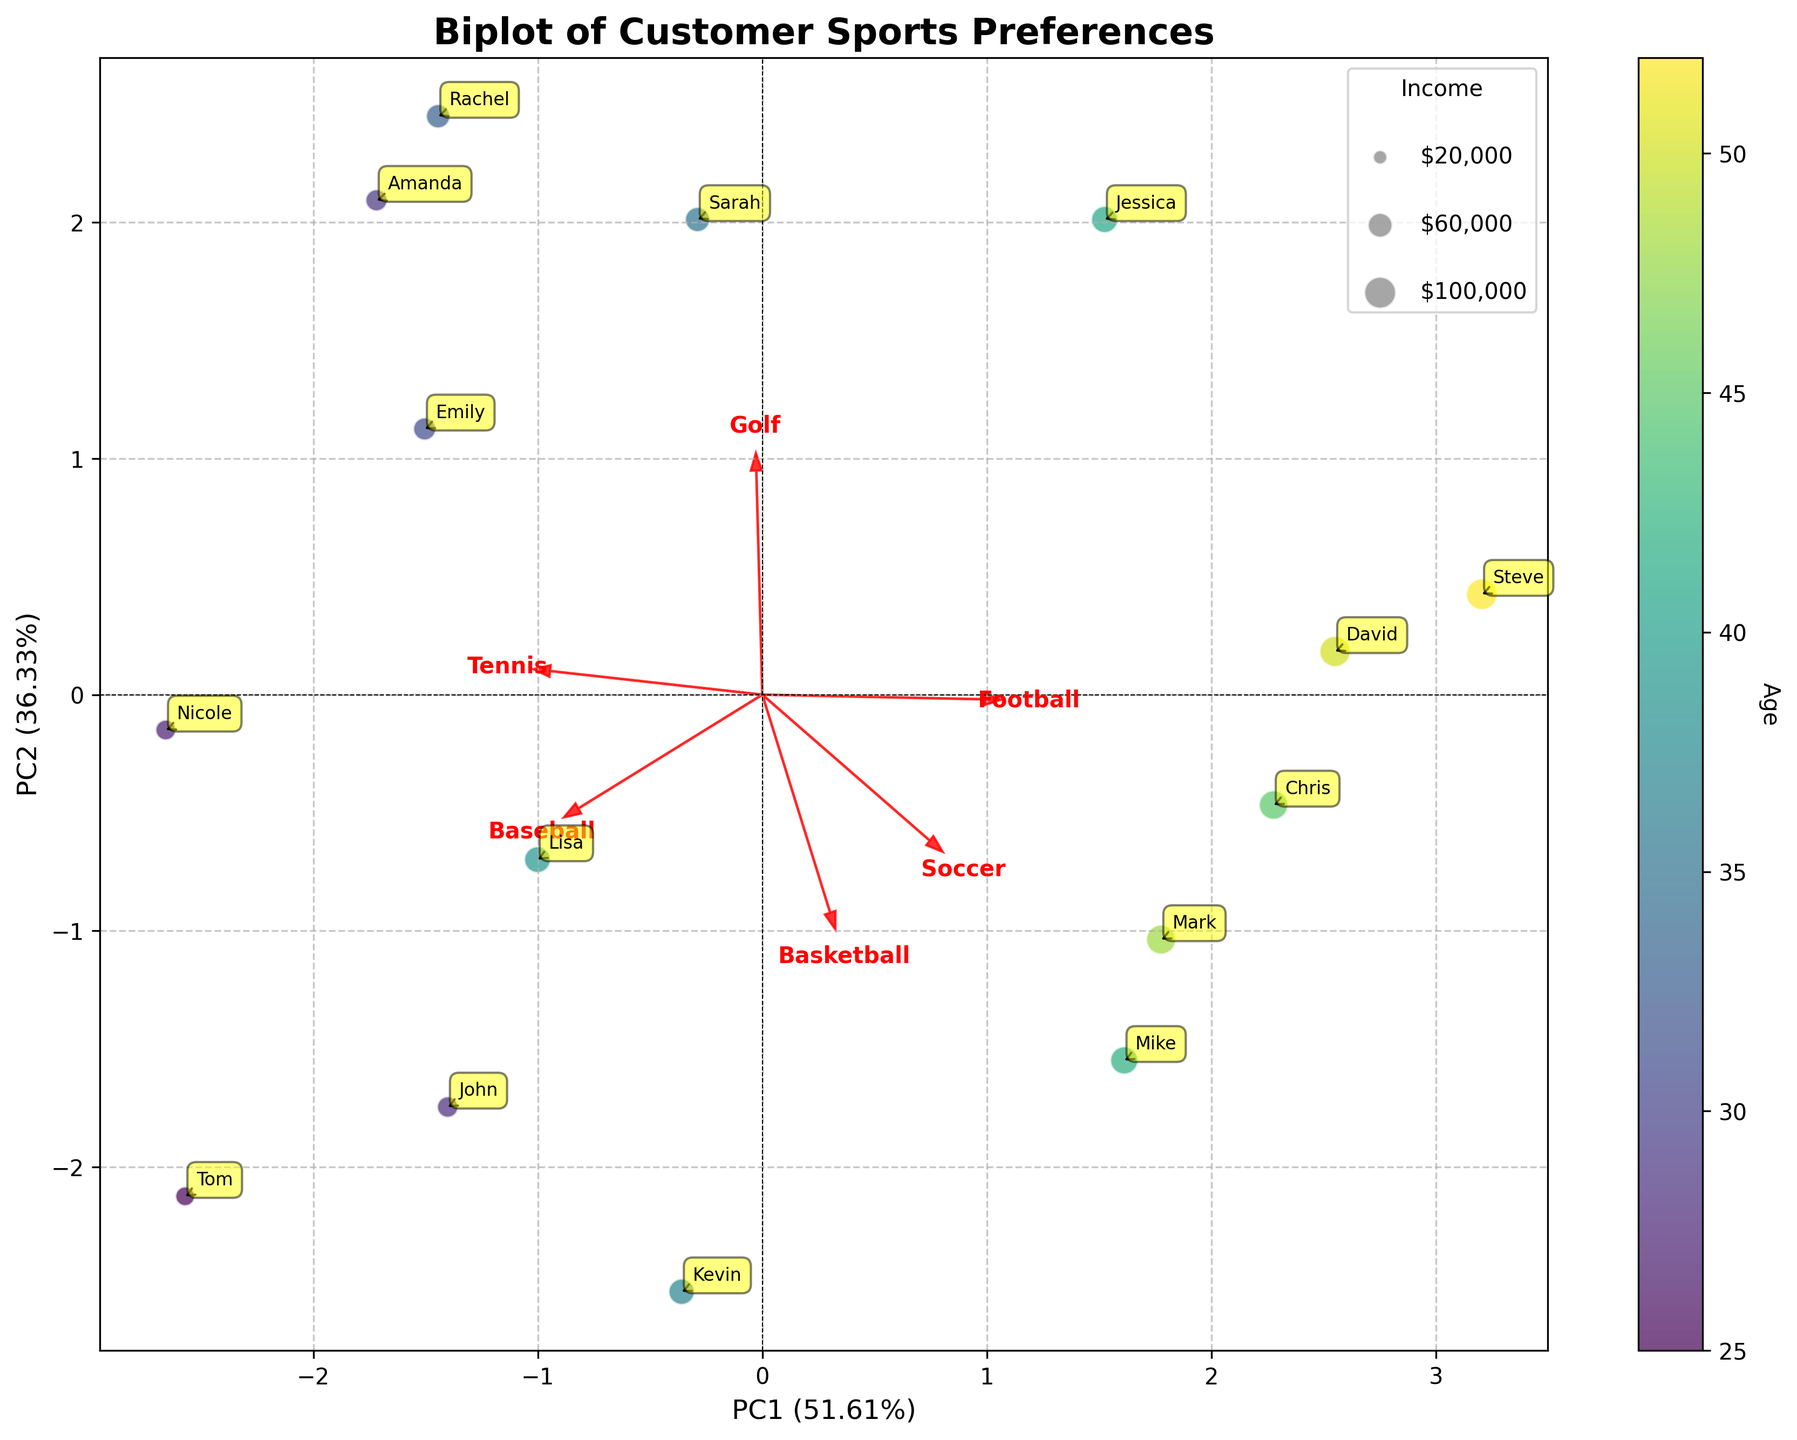What's the title of the plot? The title is usually located at the top center of the plot. In this case, the title is clearly written as "Biplot of Customer Sports Preferences".
Answer: Biplot of Customer Sports Preferences How is age represented in the plot? Age is represented through color coding. Observing the color bar on the right, which is labeled "Age", it shows a gradient indicating the range of ages.
Answer: Color How is income represented in the plot? Income is represented by the size of the circles. The legend includes circles of different sizes labeled with specific income values such as $20,000, $60,000, and $100,000.
Answer: Size of the circles Which customer has the highest income? By looking at the largest circles in the plot, you can see that "David" and "Steve" have circles representing the highest income range ($95,000 and $98,000 respectively).
Answer: David and Steve Which sport does Principal Component 1 (PC1) seem most related to? Observing the length and direction of the arrows representing each sport along PC1's axis, Football, Golf, and Baseball stretch the furthest, indicating they have strong positive loadings on PC1.
Answer: Football, Golf, and Baseball What customer name appears closest to the origin (0,0)? The closest name to the origin can be identified as "Steve" by observing which spine the label is nearest to.
Answer: Steve What is the most preferred sport of younger customers in the plot? By observing the color gradient for younger customers and the alignment of their points with the loading vectors, it seems Soccer and Basketball are popular among the younger age groups.
Answer: Soccer and Basketball Which two customers are most similar in their sport preferences? The two customers whose points are positioned closest to each other on the plot represent similar preferences. "Jessica" and "David" appear to have similar preferences based on their proximity.
Answer: Jessica and David Which sports activity has the highest loading on PC2? By looking at the arrows and their directions relative to PC2, the sport with the longest arrow in the vertical direction indicates its high loading. Tennis appears to have the highest loading on PC2.
Answer: Tennis Which customer is noted to have a high preference for Tennis and Golf? By observing the direction of arrows representing Tennis and Golf and finding the customer points in those directions, "Sarah" aligns closely with high preference for both sports.
Answer: Sarah 